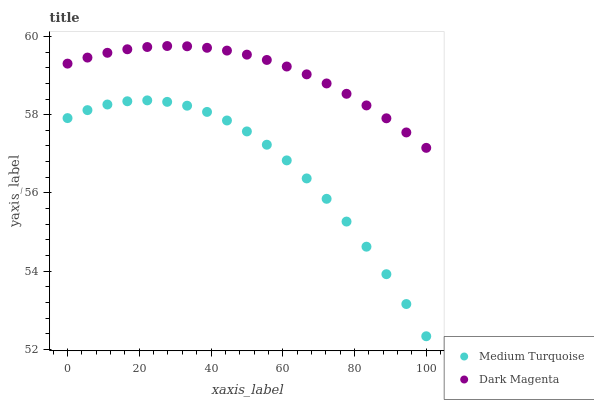Does Medium Turquoise have the minimum area under the curve?
Answer yes or no. Yes. Does Dark Magenta have the maximum area under the curve?
Answer yes or no. Yes. Does Medium Turquoise have the maximum area under the curve?
Answer yes or no. No. Is Dark Magenta the smoothest?
Answer yes or no. Yes. Is Medium Turquoise the roughest?
Answer yes or no. Yes. Is Medium Turquoise the smoothest?
Answer yes or no. No. Does Medium Turquoise have the lowest value?
Answer yes or no. Yes. Does Dark Magenta have the highest value?
Answer yes or no. Yes. Does Medium Turquoise have the highest value?
Answer yes or no. No. Is Medium Turquoise less than Dark Magenta?
Answer yes or no. Yes. Is Dark Magenta greater than Medium Turquoise?
Answer yes or no. Yes. Does Medium Turquoise intersect Dark Magenta?
Answer yes or no. No. 